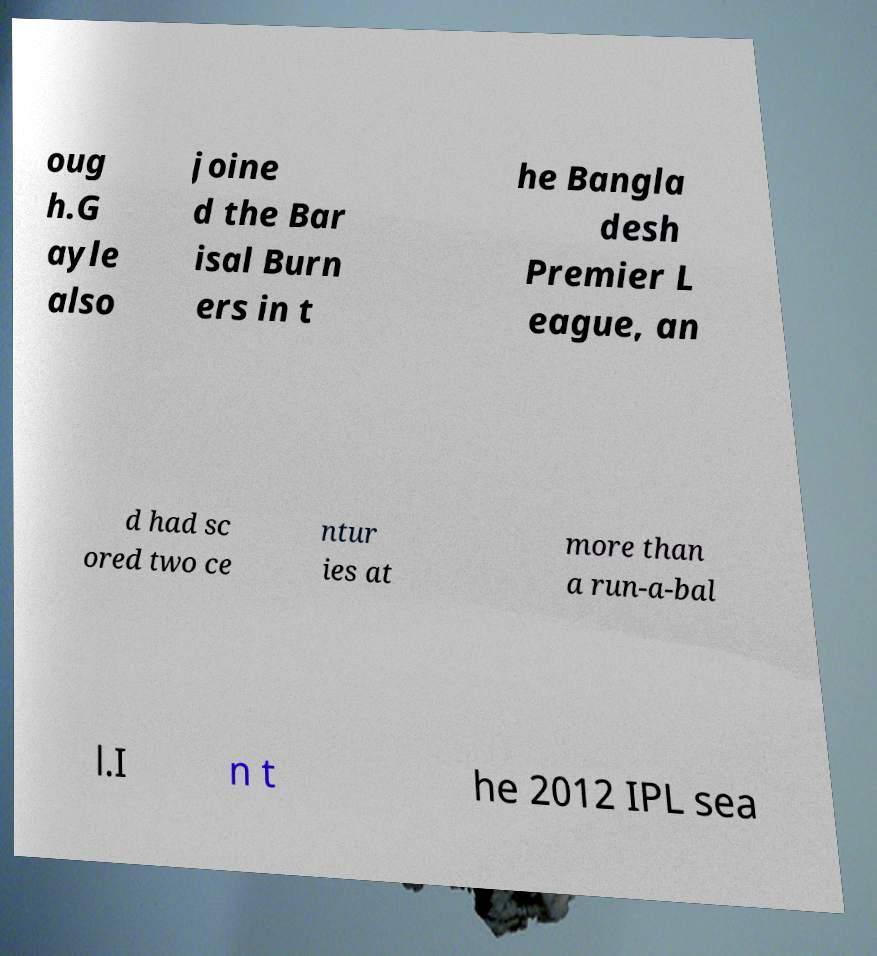For documentation purposes, I need the text within this image transcribed. Could you provide that? oug h.G ayle also joine d the Bar isal Burn ers in t he Bangla desh Premier L eague, an d had sc ored two ce ntur ies at more than a run-a-bal l.I n t he 2012 IPL sea 